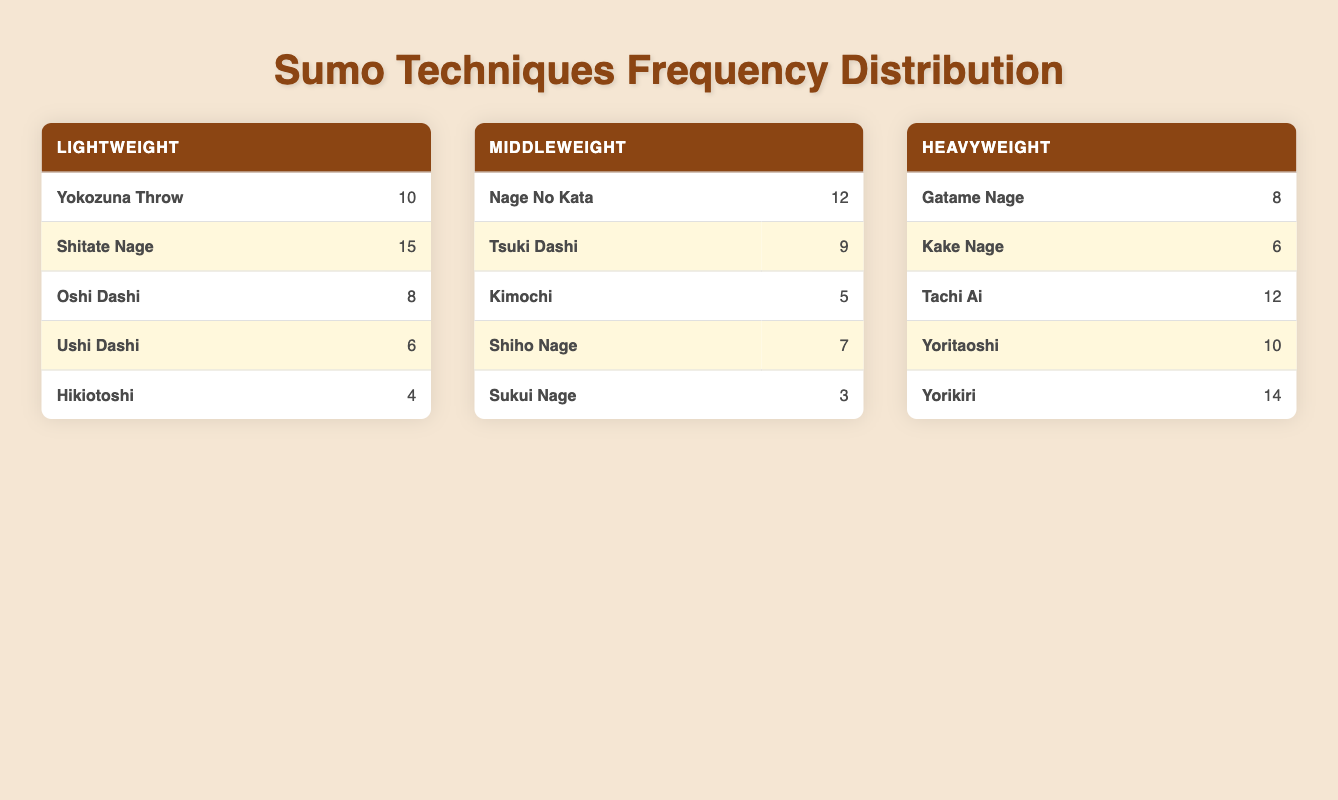What is the highest frequency technique used in the Lightweight class? The highest frequency technique in the Lightweight class can be found by comparing the values listed under that class. The techniques and their frequencies are: Yokozuna Throw (10), Shitate Nage (15), Oshi Dashi (8), Ushi Dashi (6), and Hikiotoshi (4). The maximum value here is 15, corresponding to Shitate Nage.
Answer: Shitate Nage How many techniques were used more than 10 times in the Heavyweight class? In the Heavyweight class, the techniques and their frequencies are: Gatame Nage (8), Kake Nage (6), Tachi Ai (12), Yoritaoshi (10), and Yorikiri (14). Techniques counted as more than 10 are Tachi Ai (12) and Yorikiri (14). There are two techniques meeting this criterion.
Answer: 2 What is the combined frequency of techniques that had a frequency less than 5 in the Middleweight class? In the Middleweight class, the frequencies are: Nage No Kata (12), Tsuki Dashi (9), Kimochi (5), Shiho Nage (7), and Sukui Nage (3). The only technique with a frequency less than 5 is Sukui Nage (3). Therefore, the combined frequency of techniques less than 5 is 3.
Answer: 3 Which weight class has the greatest total frequency of techniques used? To find out which weight class has the greatest total frequency, we can sum the frequencies of each class. Lightweight total: 10 + 15 + 8 + 6 + 4 = 43. Middleweight total: 12 + 9 + 5 + 7 + 3 = 36. Heavyweight total: 8 + 6 + 12 + 10 + 14 = 50. The Heavyweight class has the greatest total frequency of 50 techniques used.
Answer: Heavyweight Is the frequency of "Yorikiri" higher than the average frequency of all techniques in the Lightweight class? First, we need to determine the average frequency in the Lightweight class. The frequencies are 10, 15, 8, 6, and 4, which sum to 43. There are 5 techniques, so the average frequency is 43/5 = 8.6. The frequency of Yorikiri is found in the Heavyweight class and is 14, which is higher than 8.6. Thus, the answer is yes.
Answer: Yes 